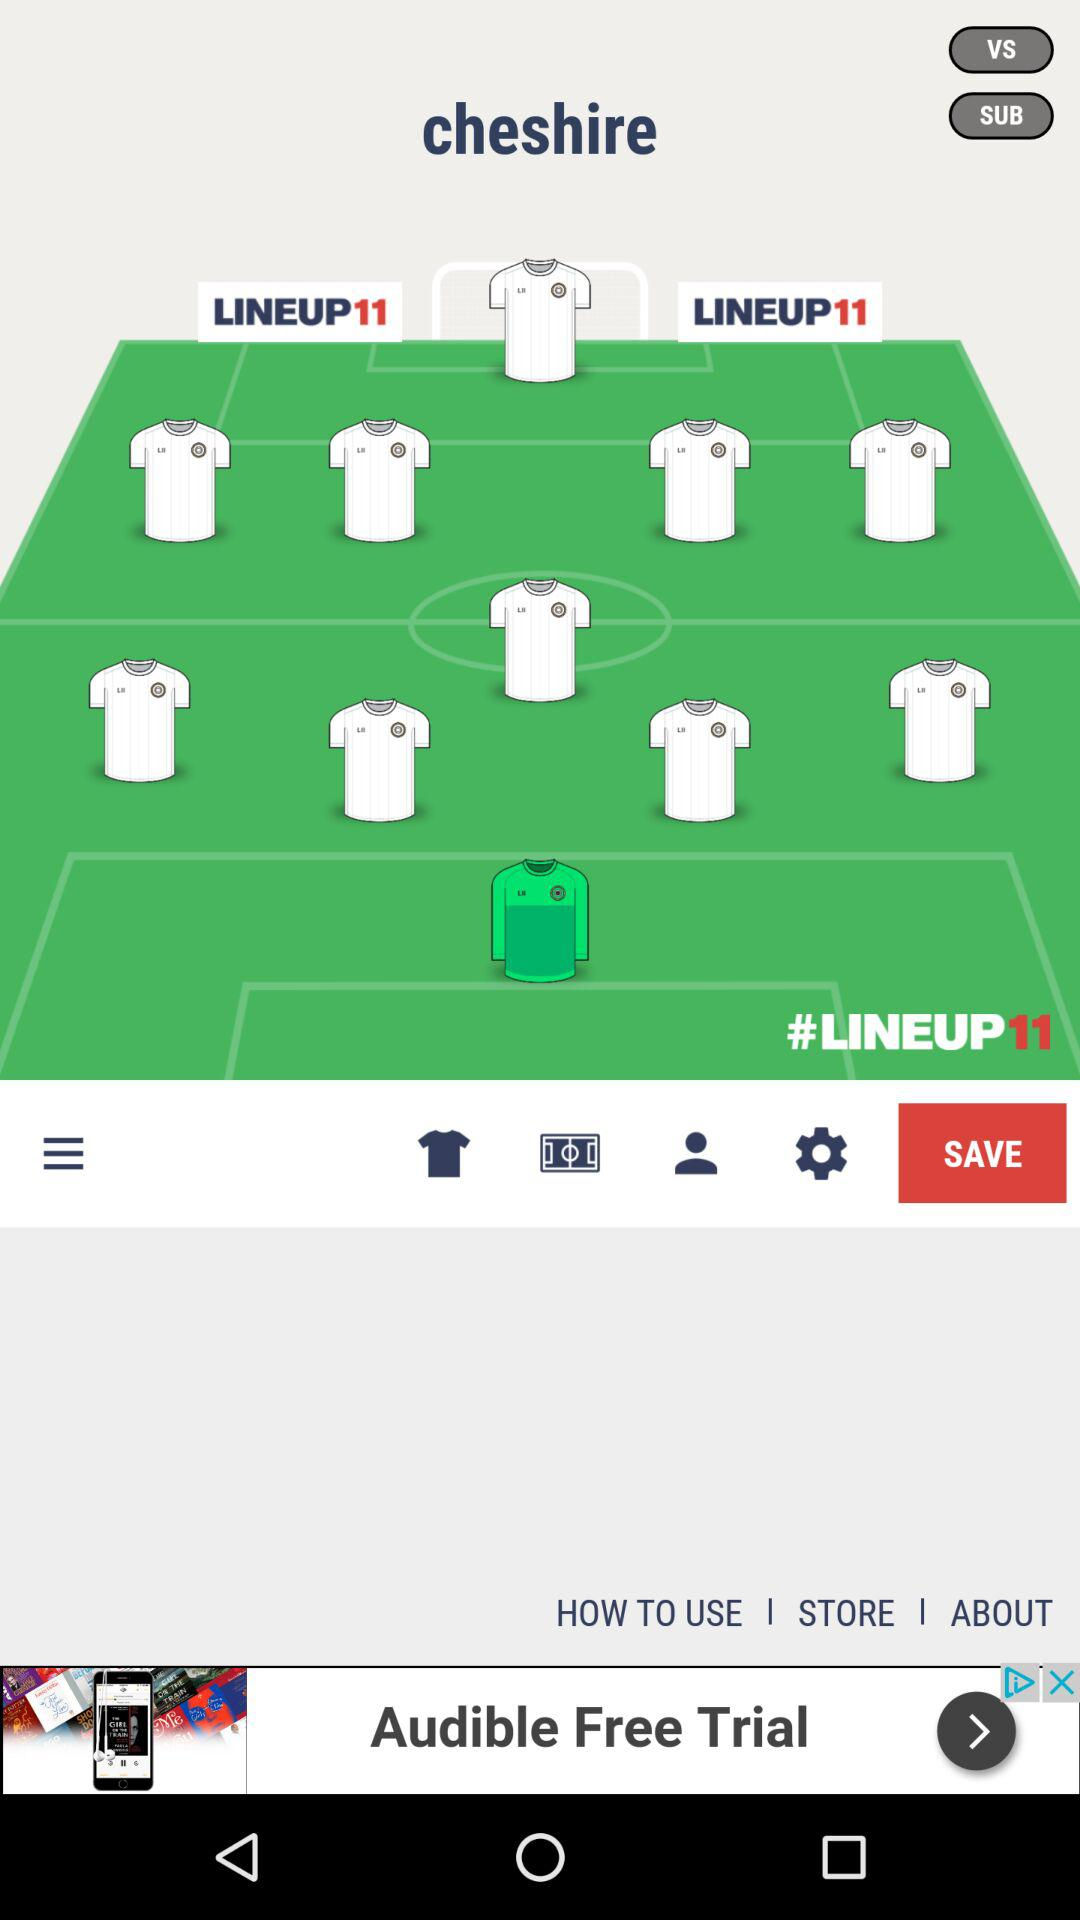How many shirts are there in the lineup?
Answer the question using a single word or phrase. 11 